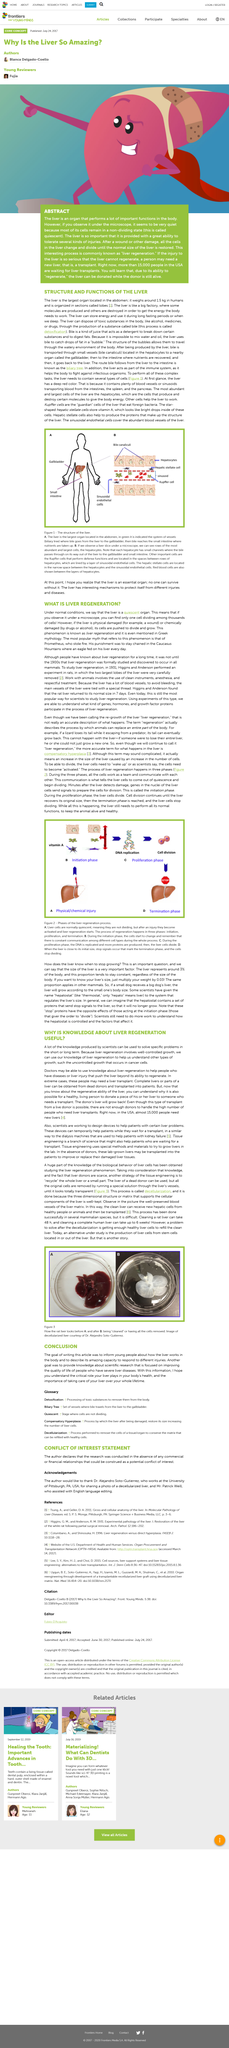Indicate a few pertinent items in this graphic. Under normal circumstances, the liver is a quiescent organ that does not perform significant functions. The phrase "liver regeneration" is used twice in the article, including the title. Prometheus' liver was fed on by an eagle. 